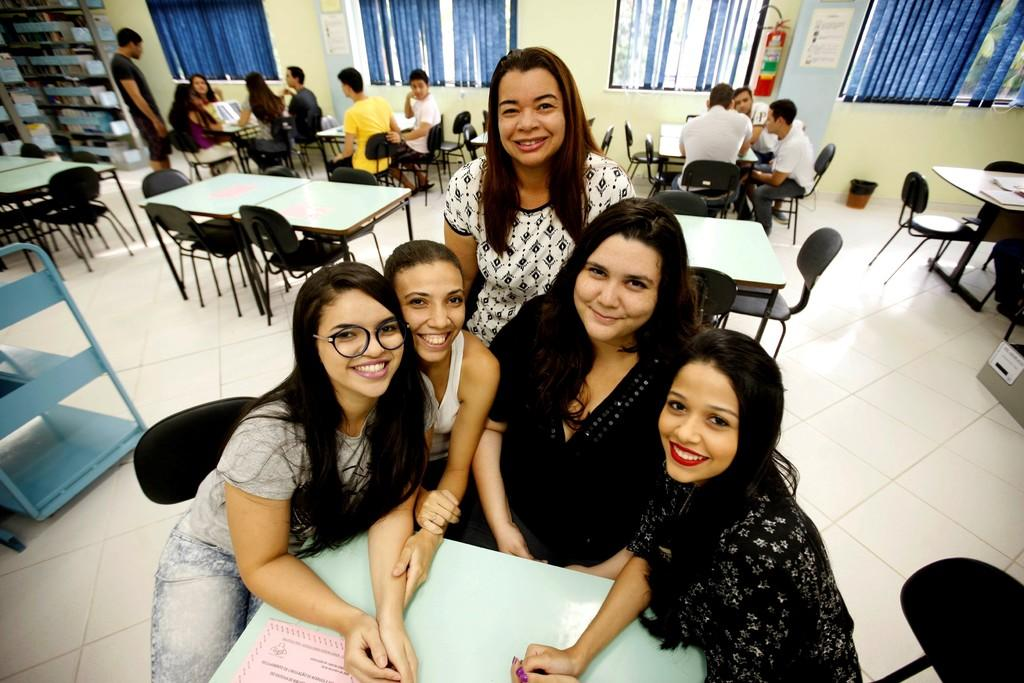How many people are in the image? There is a group of people in the image, but the exact number cannot be determined from the provided facts. What type of furniture is visible in the image? There are tables and chairs in the image. What can be used for hanging or storing items in the image? There are racks in the image for hanging or storing items. What type of window treatment is present in the image? There are curtains in the image. What type of structure is visible in the image? There is a wall in the image. What type of polish is being applied to the stage in the image? There is no stage or polish present in the image. What type of work are the people in the image engaged in? The provided facts do not indicate what type of work the people in the image are engaged in. 